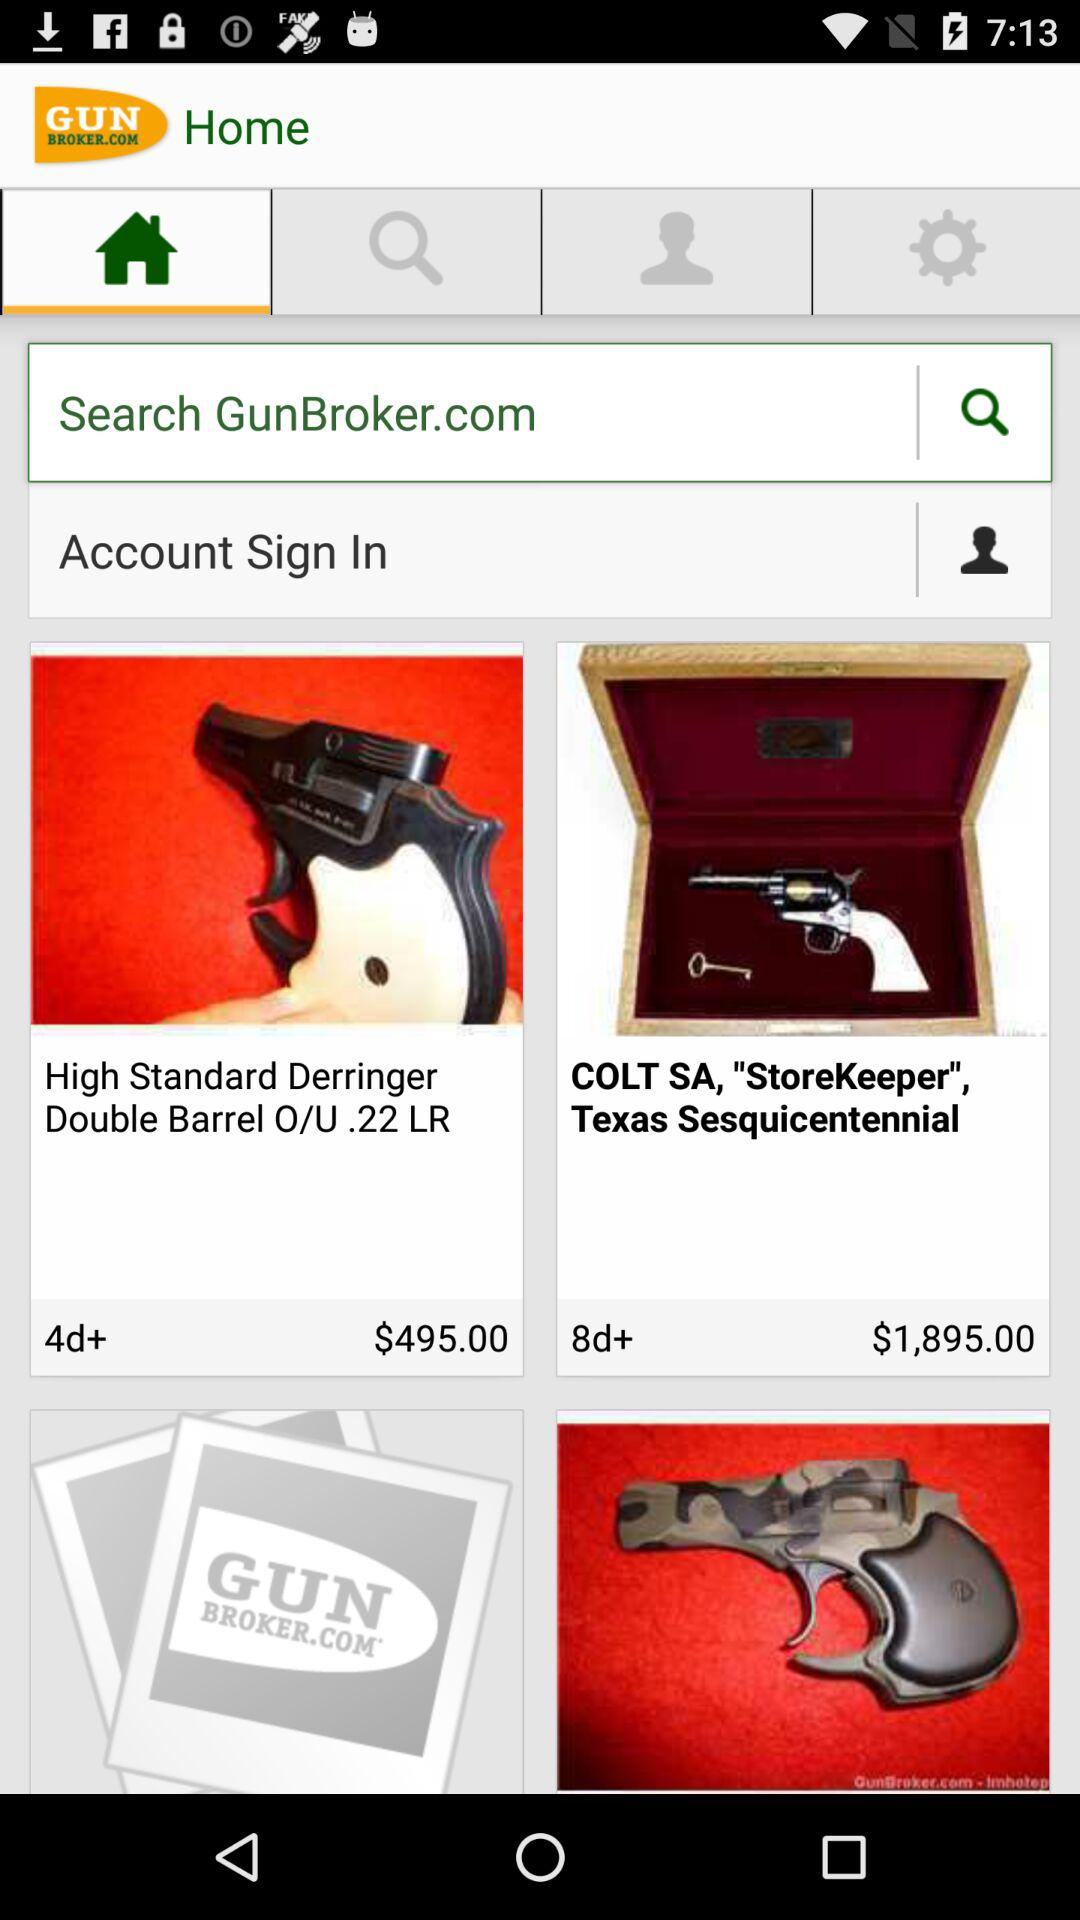What is the cost of the High Standard Derringer Double Barrel O/U.22 LR? The cost is $495. 